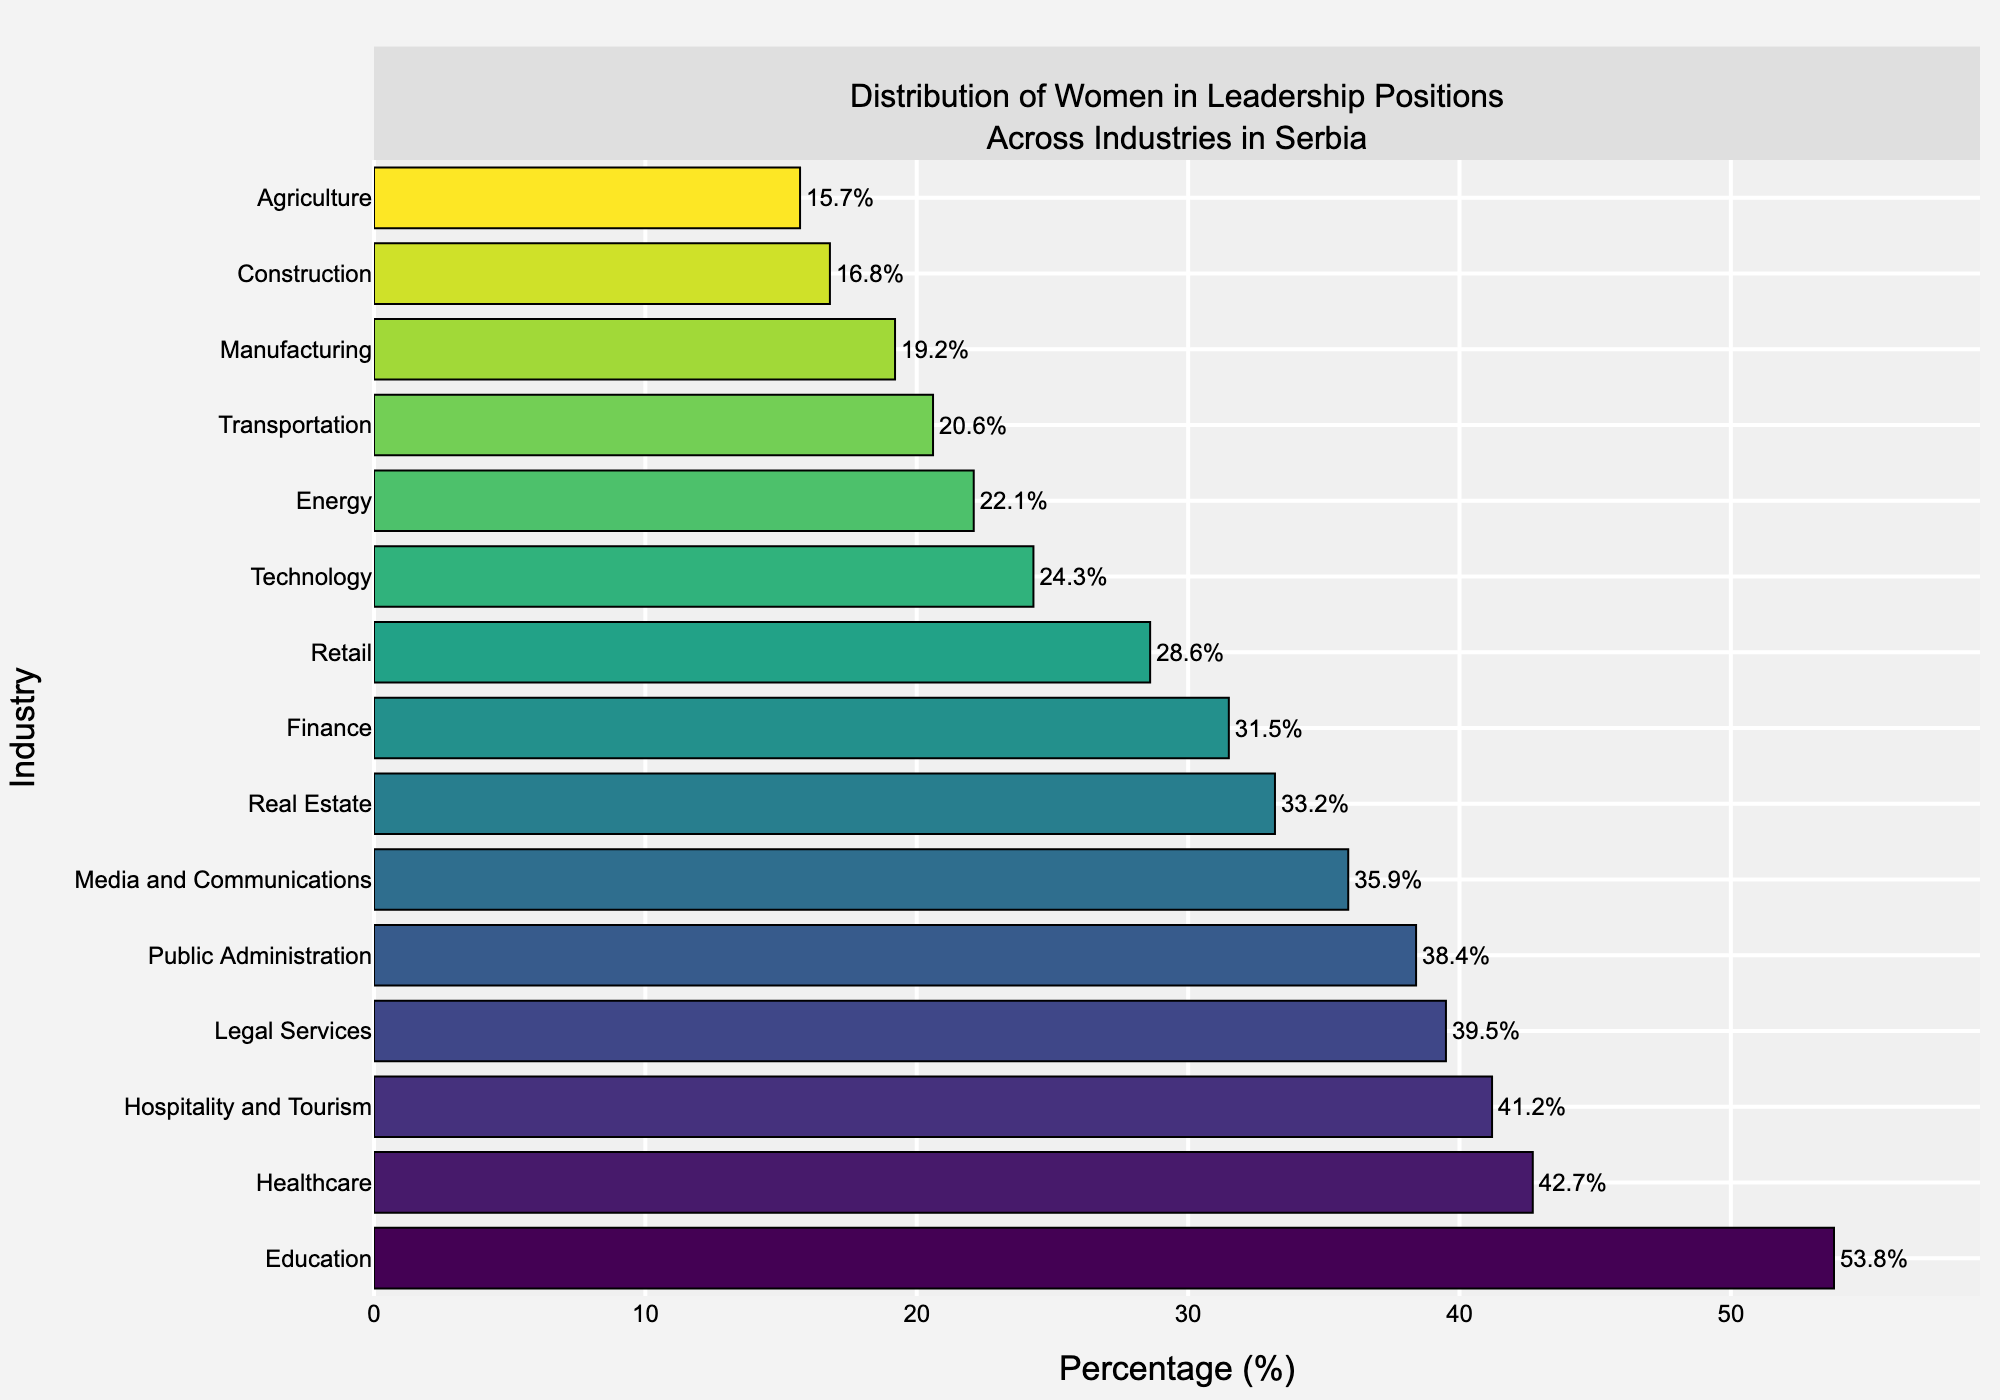What's the industry with the highest percentage of women in leadership positions? To find the industry with the highest percentage, look at the bar that extends the farthest to the right.
Answer: Education Which industry has a higher percentage of women in leadership positions, Finance or Real Estate? First, locate the bars for Finance and Real Estate. Compare their lengths or the numerical values attached to the bars.
Answer: Finance What is the difference in the percentage of women in leadership positions between Healthcare and Technology? Locate the bars for Healthcare and Technology. Note their percentages (Healthcare: 42.7%, Technology: 24.3%). Subtract the percentage of Technology from Healthcare.
Answer: 18.4% What is the average percentage of women in leadership positions across the Technology, Finance, and Healthcare industries? Sum the percentages for Technology (24.3%), Finance (31.5%), and Healthcare (42.7%) to get 98.5. Divide by the number of industries (3).
Answer: 32.8% Which industries have a percentage of women in leadership positions greater than 40%? Identify the bars that have percentages above 40%.
Answer: Healthcare, Education, Hospitality and Tourism How many industries have less than 25% of women in leadership positions? Count the bars that have percentages less than 25%.
Answer: 6 Compare the difference in the percentage of women in leadership positions between Manufacturing and Agriculture. Locate the bars for Manufacturing (19.2%) and Agriculture (15.7%). Subtract the percentage of Agriculture from Manufacturing.
Answer: 3.5% What is the median percentage of women in leadership positions across all listed industries? Arrange the percentages in ascending order: (15.7, 16.8, 19.2, 20.6, 22.1, 24.3, 28.6, 31.5, 33.2, 35.9, 38.4, 39.5, 41.2, 42.7, 53.8). The median value is the middle one in this sequence.
Answer: 31.5% Which industry has the closest percentage of women in leadership positions to the median value? The median value is 31.5%. Find the bar with the percentage closest to this value.
Answer: Finance How does the percentage of women in leadership in Education compare to that in Media and Communications? Locate and compare the bars for Education (53.8%) and Media and Communications (35.9%). Determine which one is higher.
Answer: Education 